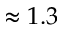Convert formula to latex. <formula><loc_0><loc_0><loc_500><loc_500>\approx 1 . 3</formula> 